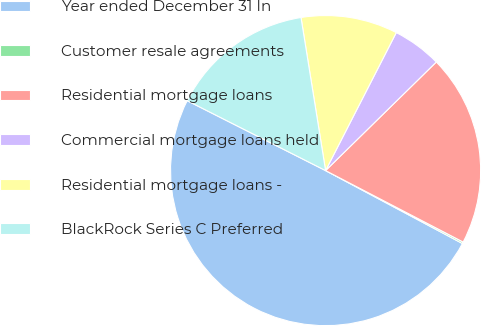<chart> <loc_0><loc_0><loc_500><loc_500><pie_chart><fcel>Year ended December 31 In<fcel>Customer resale agreements<fcel>Residential mortgage loans<fcel>Commercial mortgage loans held<fcel>Residential mortgage loans -<fcel>BlackRock Series C Preferred<nl><fcel>49.65%<fcel>0.17%<fcel>19.97%<fcel>5.12%<fcel>10.07%<fcel>15.02%<nl></chart> 